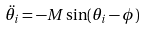Convert formula to latex. <formula><loc_0><loc_0><loc_500><loc_500>\ddot { \theta } _ { i } = - M \sin ( \theta _ { i } - \phi )</formula> 